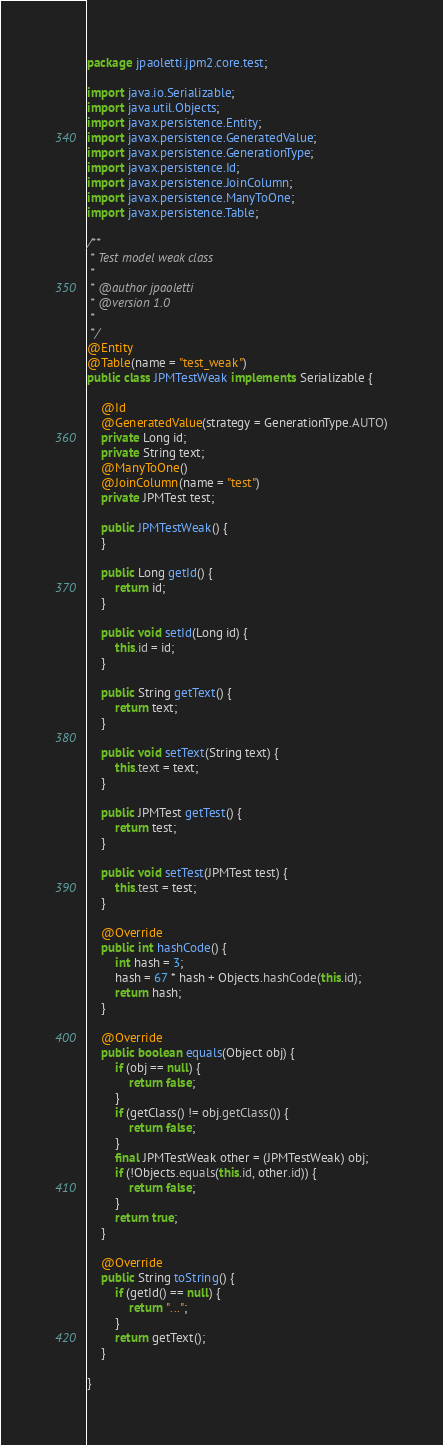<code> <loc_0><loc_0><loc_500><loc_500><_Java_>package jpaoletti.jpm2.core.test;

import java.io.Serializable;
import java.util.Objects;
import javax.persistence.Entity;
import javax.persistence.GeneratedValue;
import javax.persistence.GenerationType;
import javax.persistence.Id;
import javax.persistence.JoinColumn;
import javax.persistence.ManyToOne;
import javax.persistence.Table;

/**
 * Test model weak class
 *
 * @author jpaoletti
 * @version 1.0
 *
 */
@Entity
@Table(name = "test_weak")
public class JPMTestWeak implements Serializable {

    @Id
    @GeneratedValue(strategy = GenerationType.AUTO)
    private Long id;
    private String text;
    @ManyToOne()
    @JoinColumn(name = "test")
    private JPMTest test;

    public JPMTestWeak() {
    }

    public Long getId() {
        return id;
    }

    public void setId(Long id) {
        this.id = id;
    }

    public String getText() {
        return text;
    }

    public void setText(String text) {
        this.text = text;
    }

    public JPMTest getTest() {
        return test;
    }

    public void setTest(JPMTest test) {
        this.test = test;
    }

    @Override
    public int hashCode() {
        int hash = 3;
        hash = 67 * hash + Objects.hashCode(this.id);
        return hash;
    }

    @Override
    public boolean equals(Object obj) {
        if (obj == null) {
            return false;
        }
        if (getClass() != obj.getClass()) {
            return false;
        }
        final JPMTestWeak other = (JPMTestWeak) obj;
        if (!Objects.equals(this.id, other.id)) {
            return false;
        }
        return true;
    }

    @Override
    public String toString() {
        if (getId() == null) {
            return "...";
        }
        return getText();
    }

}
</code> 